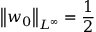Convert formula to latex. <formula><loc_0><loc_0><loc_500><loc_500>\left \| w _ { 0 } \right \| _ { L ^ { \infty } } = \frac { 1 } { 2 }</formula> 